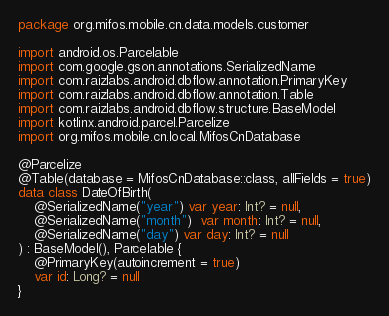Convert code to text. <code><loc_0><loc_0><loc_500><loc_500><_Kotlin_>package org.mifos.mobile.cn.data.models.customer

import android.os.Parcelable
import com.google.gson.annotations.SerializedName
import com.raizlabs.android.dbflow.annotation.PrimaryKey
import com.raizlabs.android.dbflow.annotation.Table
import com.raizlabs.android.dbflow.structure.BaseModel
import kotlinx.android.parcel.Parcelize
import org.mifos.mobile.cn.local.MifosCnDatabase

@Parcelize
@Table(database = MifosCnDatabase::class, allFields = true)
data class DateOfBirth(
    @SerializedName("year") var year: Int? = null,
    @SerializedName("month")  var month: Int? = null,
    @SerializedName("day") var day: Int? = null
) : BaseModel(), Parcelable {
    @PrimaryKey(autoincrement = true)
    var id: Long? = null
}</code> 